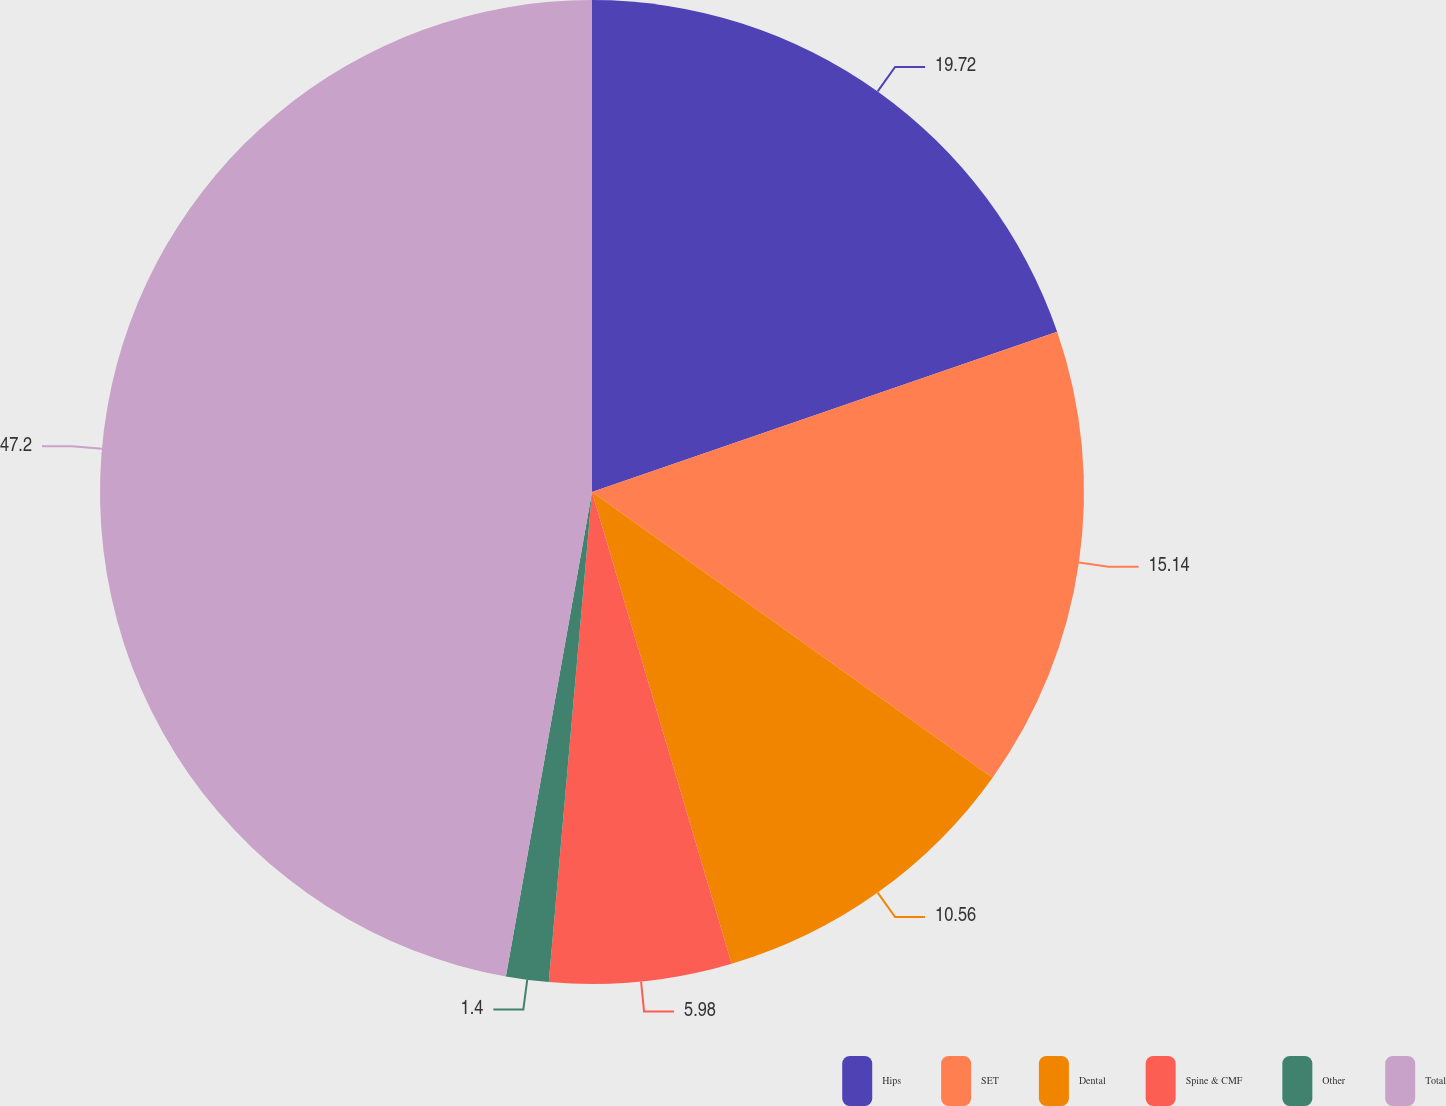<chart> <loc_0><loc_0><loc_500><loc_500><pie_chart><fcel>Hips<fcel>SET<fcel>Dental<fcel>Spine & CMF<fcel>Other<fcel>Total<nl><fcel>19.72%<fcel>15.14%<fcel>10.56%<fcel>5.98%<fcel>1.4%<fcel>47.2%<nl></chart> 